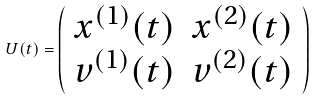Convert formula to latex. <formula><loc_0><loc_0><loc_500><loc_500>U ( t ) = \left ( \begin{array} { c c } x ^ { ( 1 ) } ( t ) & x ^ { ( 2 ) } ( t ) \\ v ^ { ( 1 ) } ( t ) & v ^ { ( 2 ) } ( t ) \end{array} \right )</formula> 